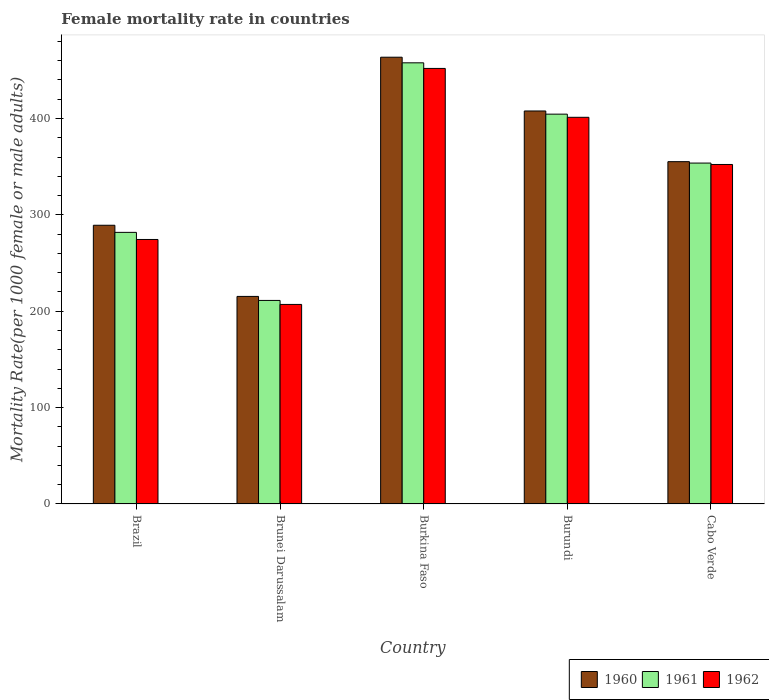How many different coloured bars are there?
Provide a short and direct response. 3. How many bars are there on the 4th tick from the right?
Ensure brevity in your answer.  3. What is the label of the 3rd group of bars from the left?
Keep it short and to the point. Burkina Faso. In how many cases, is the number of bars for a given country not equal to the number of legend labels?
Ensure brevity in your answer.  0. What is the female mortality rate in 1960 in Burundi?
Offer a terse response. 407.84. Across all countries, what is the maximum female mortality rate in 1960?
Your answer should be compact. 463.65. Across all countries, what is the minimum female mortality rate in 1960?
Your answer should be compact. 215.4. In which country was the female mortality rate in 1962 maximum?
Make the answer very short. Burkina Faso. In which country was the female mortality rate in 1962 minimum?
Your answer should be very brief. Brunei Darussalam. What is the total female mortality rate in 1961 in the graph?
Your answer should be very brief. 1709.28. What is the difference between the female mortality rate in 1961 in Burundi and that in Cabo Verde?
Provide a succinct answer. 50.78. What is the difference between the female mortality rate in 1960 in Burundi and the female mortality rate in 1961 in Brunei Darussalam?
Ensure brevity in your answer.  196.6. What is the average female mortality rate in 1962 per country?
Your answer should be compact. 337.44. What is the difference between the female mortality rate of/in 1962 and female mortality rate of/in 1961 in Brunei Darussalam?
Your response must be concise. -4.16. In how many countries, is the female mortality rate in 1961 greater than 80?
Provide a succinct answer. 5. What is the ratio of the female mortality rate in 1962 in Brazil to that in Cabo Verde?
Offer a very short reply. 0.78. Is the female mortality rate in 1961 in Brunei Darussalam less than that in Burkina Faso?
Ensure brevity in your answer.  Yes. What is the difference between the highest and the second highest female mortality rate in 1960?
Your response must be concise. 52.6. What is the difference between the highest and the lowest female mortality rate in 1960?
Your answer should be very brief. 248.25. In how many countries, is the female mortality rate in 1960 greater than the average female mortality rate in 1960 taken over all countries?
Ensure brevity in your answer.  3. What does the 2nd bar from the right in Burkina Faso represents?
Offer a terse response. 1961. How many bars are there?
Give a very brief answer. 15. Are all the bars in the graph horizontal?
Offer a terse response. No. How many countries are there in the graph?
Give a very brief answer. 5. Are the values on the major ticks of Y-axis written in scientific E-notation?
Give a very brief answer. No. Does the graph contain grids?
Your answer should be compact. No. How are the legend labels stacked?
Give a very brief answer. Horizontal. What is the title of the graph?
Your answer should be very brief. Female mortality rate in countries. Does "1991" appear as one of the legend labels in the graph?
Make the answer very short. No. What is the label or title of the X-axis?
Keep it short and to the point. Country. What is the label or title of the Y-axis?
Offer a terse response. Mortality Rate(per 1000 female or male adults). What is the Mortality Rate(per 1000 female or male adults) in 1960 in Brazil?
Your answer should be compact. 289.25. What is the Mortality Rate(per 1000 female or male adults) of 1961 in Brazil?
Provide a succinct answer. 281.87. What is the Mortality Rate(per 1000 female or male adults) in 1962 in Brazil?
Provide a succinct answer. 274.49. What is the Mortality Rate(per 1000 female or male adults) of 1960 in Brunei Darussalam?
Provide a short and direct response. 215.4. What is the Mortality Rate(per 1000 female or male adults) in 1961 in Brunei Darussalam?
Your response must be concise. 211.24. What is the Mortality Rate(per 1000 female or male adults) in 1962 in Brunei Darussalam?
Make the answer very short. 207.09. What is the Mortality Rate(per 1000 female or male adults) of 1960 in Burkina Faso?
Keep it short and to the point. 463.65. What is the Mortality Rate(per 1000 female or male adults) in 1961 in Burkina Faso?
Offer a terse response. 457.83. What is the Mortality Rate(per 1000 female or male adults) in 1962 in Burkina Faso?
Provide a short and direct response. 452. What is the Mortality Rate(per 1000 female or male adults) of 1960 in Burundi?
Make the answer very short. 407.84. What is the Mortality Rate(per 1000 female or male adults) in 1961 in Burundi?
Provide a succinct answer. 404.56. What is the Mortality Rate(per 1000 female or male adults) in 1962 in Burundi?
Give a very brief answer. 401.28. What is the Mortality Rate(per 1000 female or male adults) of 1960 in Cabo Verde?
Offer a very short reply. 355.24. What is the Mortality Rate(per 1000 female or male adults) in 1961 in Cabo Verde?
Your response must be concise. 353.78. What is the Mortality Rate(per 1000 female or male adults) in 1962 in Cabo Verde?
Offer a very short reply. 352.33. Across all countries, what is the maximum Mortality Rate(per 1000 female or male adults) of 1960?
Provide a succinct answer. 463.65. Across all countries, what is the maximum Mortality Rate(per 1000 female or male adults) of 1961?
Make the answer very short. 457.83. Across all countries, what is the maximum Mortality Rate(per 1000 female or male adults) in 1962?
Ensure brevity in your answer.  452. Across all countries, what is the minimum Mortality Rate(per 1000 female or male adults) in 1960?
Give a very brief answer. 215.4. Across all countries, what is the minimum Mortality Rate(per 1000 female or male adults) in 1961?
Keep it short and to the point. 211.24. Across all countries, what is the minimum Mortality Rate(per 1000 female or male adults) in 1962?
Offer a very short reply. 207.09. What is the total Mortality Rate(per 1000 female or male adults) of 1960 in the graph?
Give a very brief answer. 1731.39. What is the total Mortality Rate(per 1000 female or male adults) in 1961 in the graph?
Offer a terse response. 1709.29. What is the total Mortality Rate(per 1000 female or male adults) of 1962 in the graph?
Ensure brevity in your answer.  1687.18. What is the difference between the Mortality Rate(per 1000 female or male adults) in 1960 in Brazil and that in Brunei Darussalam?
Offer a very short reply. 73.86. What is the difference between the Mortality Rate(per 1000 female or male adults) of 1961 in Brazil and that in Brunei Darussalam?
Provide a short and direct response. 70.63. What is the difference between the Mortality Rate(per 1000 female or male adults) in 1962 in Brazil and that in Brunei Darussalam?
Your answer should be very brief. 67.41. What is the difference between the Mortality Rate(per 1000 female or male adults) of 1960 in Brazil and that in Burkina Faso?
Your answer should be very brief. -174.39. What is the difference between the Mortality Rate(per 1000 female or male adults) in 1961 in Brazil and that in Burkina Faso?
Offer a terse response. -175.95. What is the difference between the Mortality Rate(per 1000 female or male adults) of 1962 in Brazil and that in Burkina Faso?
Your answer should be compact. -177.51. What is the difference between the Mortality Rate(per 1000 female or male adults) in 1960 in Brazil and that in Burundi?
Offer a very short reply. -118.59. What is the difference between the Mortality Rate(per 1000 female or male adults) in 1961 in Brazil and that in Burundi?
Your response must be concise. -122.69. What is the difference between the Mortality Rate(per 1000 female or male adults) in 1962 in Brazil and that in Burundi?
Provide a succinct answer. -126.78. What is the difference between the Mortality Rate(per 1000 female or male adults) of 1960 in Brazil and that in Cabo Verde?
Your answer should be compact. -65.99. What is the difference between the Mortality Rate(per 1000 female or male adults) in 1961 in Brazil and that in Cabo Verde?
Your answer should be compact. -71.91. What is the difference between the Mortality Rate(per 1000 female or male adults) in 1962 in Brazil and that in Cabo Verde?
Your answer should be compact. -77.83. What is the difference between the Mortality Rate(per 1000 female or male adults) of 1960 in Brunei Darussalam and that in Burkina Faso?
Your response must be concise. -248.25. What is the difference between the Mortality Rate(per 1000 female or male adults) in 1961 in Brunei Darussalam and that in Burkina Faso?
Ensure brevity in your answer.  -246.58. What is the difference between the Mortality Rate(per 1000 female or male adults) in 1962 in Brunei Darussalam and that in Burkina Faso?
Provide a succinct answer. -244.92. What is the difference between the Mortality Rate(per 1000 female or male adults) of 1960 in Brunei Darussalam and that in Burundi?
Provide a succinct answer. -192.44. What is the difference between the Mortality Rate(per 1000 female or male adults) of 1961 in Brunei Darussalam and that in Burundi?
Keep it short and to the point. -193.32. What is the difference between the Mortality Rate(per 1000 female or male adults) in 1962 in Brunei Darussalam and that in Burundi?
Provide a short and direct response. -194.19. What is the difference between the Mortality Rate(per 1000 female or male adults) in 1960 in Brunei Darussalam and that in Cabo Verde?
Offer a very short reply. -139.84. What is the difference between the Mortality Rate(per 1000 female or male adults) of 1961 in Brunei Darussalam and that in Cabo Verde?
Give a very brief answer. -142.54. What is the difference between the Mortality Rate(per 1000 female or male adults) in 1962 in Brunei Darussalam and that in Cabo Verde?
Provide a succinct answer. -145.24. What is the difference between the Mortality Rate(per 1000 female or male adults) in 1960 in Burkina Faso and that in Burundi?
Offer a terse response. 55.8. What is the difference between the Mortality Rate(per 1000 female or male adults) of 1961 in Burkina Faso and that in Burundi?
Keep it short and to the point. 53.27. What is the difference between the Mortality Rate(per 1000 female or male adults) of 1962 in Burkina Faso and that in Burundi?
Offer a very short reply. 50.73. What is the difference between the Mortality Rate(per 1000 female or male adults) of 1960 in Burkina Faso and that in Cabo Verde?
Ensure brevity in your answer.  108.41. What is the difference between the Mortality Rate(per 1000 female or male adults) in 1961 in Burkina Faso and that in Cabo Verde?
Your answer should be compact. 104.04. What is the difference between the Mortality Rate(per 1000 female or male adults) in 1962 in Burkina Faso and that in Cabo Verde?
Ensure brevity in your answer.  99.68. What is the difference between the Mortality Rate(per 1000 female or male adults) of 1960 in Burundi and that in Cabo Verde?
Provide a succinct answer. 52.6. What is the difference between the Mortality Rate(per 1000 female or male adults) in 1961 in Burundi and that in Cabo Verde?
Make the answer very short. 50.78. What is the difference between the Mortality Rate(per 1000 female or male adults) in 1962 in Burundi and that in Cabo Verde?
Keep it short and to the point. 48.95. What is the difference between the Mortality Rate(per 1000 female or male adults) of 1960 in Brazil and the Mortality Rate(per 1000 female or male adults) of 1961 in Brunei Darussalam?
Provide a short and direct response. 78.01. What is the difference between the Mortality Rate(per 1000 female or male adults) in 1960 in Brazil and the Mortality Rate(per 1000 female or male adults) in 1962 in Brunei Darussalam?
Your response must be concise. 82.17. What is the difference between the Mortality Rate(per 1000 female or male adults) of 1961 in Brazil and the Mortality Rate(per 1000 female or male adults) of 1962 in Brunei Darussalam?
Provide a short and direct response. 74.79. What is the difference between the Mortality Rate(per 1000 female or male adults) of 1960 in Brazil and the Mortality Rate(per 1000 female or male adults) of 1961 in Burkina Faso?
Your answer should be very brief. -168.57. What is the difference between the Mortality Rate(per 1000 female or male adults) of 1960 in Brazil and the Mortality Rate(per 1000 female or male adults) of 1962 in Burkina Faso?
Your answer should be compact. -162.75. What is the difference between the Mortality Rate(per 1000 female or male adults) of 1961 in Brazil and the Mortality Rate(per 1000 female or male adults) of 1962 in Burkina Faso?
Offer a terse response. -170.13. What is the difference between the Mortality Rate(per 1000 female or male adults) of 1960 in Brazil and the Mortality Rate(per 1000 female or male adults) of 1961 in Burundi?
Your answer should be very brief. -115.31. What is the difference between the Mortality Rate(per 1000 female or male adults) in 1960 in Brazil and the Mortality Rate(per 1000 female or male adults) in 1962 in Burundi?
Ensure brevity in your answer.  -112.02. What is the difference between the Mortality Rate(per 1000 female or male adults) of 1961 in Brazil and the Mortality Rate(per 1000 female or male adults) of 1962 in Burundi?
Offer a very short reply. -119.4. What is the difference between the Mortality Rate(per 1000 female or male adults) in 1960 in Brazil and the Mortality Rate(per 1000 female or male adults) in 1961 in Cabo Verde?
Give a very brief answer. -64.53. What is the difference between the Mortality Rate(per 1000 female or male adults) of 1960 in Brazil and the Mortality Rate(per 1000 female or male adults) of 1962 in Cabo Verde?
Make the answer very short. -63.07. What is the difference between the Mortality Rate(per 1000 female or male adults) in 1961 in Brazil and the Mortality Rate(per 1000 female or male adults) in 1962 in Cabo Verde?
Your response must be concise. -70.45. What is the difference between the Mortality Rate(per 1000 female or male adults) of 1960 in Brunei Darussalam and the Mortality Rate(per 1000 female or male adults) of 1961 in Burkina Faso?
Ensure brevity in your answer.  -242.43. What is the difference between the Mortality Rate(per 1000 female or male adults) of 1960 in Brunei Darussalam and the Mortality Rate(per 1000 female or male adults) of 1962 in Burkina Faso?
Ensure brevity in your answer.  -236.61. What is the difference between the Mortality Rate(per 1000 female or male adults) of 1961 in Brunei Darussalam and the Mortality Rate(per 1000 female or male adults) of 1962 in Burkina Faso?
Provide a short and direct response. -240.76. What is the difference between the Mortality Rate(per 1000 female or male adults) in 1960 in Brunei Darussalam and the Mortality Rate(per 1000 female or male adults) in 1961 in Burundi?
Give a very brief answer. -189.16. What is the difference between the Mortality Rate(per 1000 female or male adults) in 1960 in Brunei Darussalam and the Mortality Rate(per 1000 female or male adults) in 1962 in Burundi?
Make the answer very short. -185.88. What is the difference between the Mortality Rate(per 1000 female or male adults) of 1961 in Brunei Darussalam and the Mortality Rate(per 1000 female or male adults) of 1962 in Burundi?
Give a very brief answer. -190.03. What is the difference between the Mortality Rate(per 1000 female or male adults) of 1960 in Brunei Darussalam and the Mortality Rate(per 1000 female or male adults) of 1961 in Cabo Verde?
Provide a short and direct response. -138.38. What is the difference between the Mortality Rate(per 1000 female or male adults) of 1960 in Brunei Darussalam and the Mortality Rate(per 1000 female or male adults) of 1962 in Cabo Verde?
Your answer should be compact. -136.93. What is the difference between the Mortality Rate(per 1000 female or male adults) in 1961 in Brunei Darussalam and the Mortality Rate(per 1000 female or male adults) in 1962 in Cabo Verde?
Provide a succinct answer. -141.08. What is the difference between the Mortality Rate(per 1000 female or male adults) of 1960 in Burkina Faso and the Mortality Rate(per 1000 female or male adults) of 1961 in Burundi?
Your answer should be very brief. 59.09. What is the difference between the Mortality Rate(per 1000 female or male adults) of 1960 in Burkina Faso and the Mortality Rate(per 1000 female or male adults) of 1962 in Burundi?
Keep it short and to the point. 62.37. What is the difference between the Mortality Rate(per 1000 female or male adults) of 1961 in Burkina Faso and the Mortality Rate(per 1000 female or male adults) of 1962 in Burundi?
Provide a short and direct response. 56.55. What is the difference between the Mortality Rate(per 1000 female or male adults) of 1960 in Burkina Faso and the Mortality Rate(per 1000 female or male adults) of 1961 in Cabo Verde?
Offer a terse response. 109.86. What is the difference between the Mortality Rate(per 1000 female or male adults) in 1960 in Burkina Faso and the Mortality Rate(per 1000 female or male adults) in 1962 in Cabo Verde?
Give a very brief answer. 111.32. What is the difference between the Mortality Rate(per 1000 female or male adults) of 1961 in Burkina Faso and the Mortality Rate(per 1000 female or male adults) of 1962 in Cabo Verde?
Make the answer very short. 105.5. What is the difference between the Mortality Rate(per 1000 female or male adults) in 1960 in Burundi and the Mortality Rate(per 1000 female or male adults) in 1961 in Cabo Verde?
Offer a terse response. 54.06. What is the difference between the Mortality Rate(per 1000 female or male adults) of 1960 in Burundi and the Mortality Rate(per 1000 female or male adults) of 1962 in Cabo Verde?
Provide a succinct answer. 55.52. What is the difference between the Mortality Rate(per 1000 female or male adults) in 1961 in Burundi and the Mortality Rate(per 1000 female or male adults) in 1962 in Cabo Verde?
Your response must be concise. 52.23. What is the average Mortality Rate(per 1000 female or male adults) in 1960 per country?
Ensure brevity in your answer.  346.28. What is the average Mortality Rate(per 1000 female or male adults) in 1961 per country?
Your response must be concise. 341.86. What is the average Mortality Rate(per 1000 female or male adults) in 1962 per country?
Ensure brevity in your answer.  337.44. What is the difference between the Mortality Rate(per 1000 female or male adults) in 1960 and Mortality Rate(per 1000 female or male adults) in 1961 in Brazil?
Your response must be concise. 7.38. What is the difference between the Mortality Rate(per 1000 female or male adults) in 1960 and Mortality Rate(per 1000 female or male adults) in 1962 in Brazil?
Ensure brevity in your answer.  14.76. What is the difference between the Mortality Rate(per 1000 female or male adults) in 1961 and Mortality Rate(per 1000 female or male adults) in 1962 in Brazil?
Ensure brevity in your answer.  7.38. What is the difference between the Mortality Rate(per 1000 female or male adults) in 1960 and Mortality Rate(per 1000 female or male adults) in 1961 in Brunei Darussalam?
Your answer should be very brief. 4.16. What is the difference between the Mortality Rate(per 1000 female or male adults) of 1960 and Mortality Rate(per 1000 female or male adults) of 1962 in Brunei Darussalam?
Provide a succinct answer. 8.31. What is the difference between the Mortality Rate(per 1000 female or male adults) of 1961 and Mortality Rate(per 1000 female or male adults) of 1962 in Brunei Darussalam?
Give a very brief answer. 4.16. What is the difference between the Mortality Rate(per 1000 female or male adults) in 1960 and Mortality Rate(per 1000 female or male adults) in 1961 in Burkina Faso?
Provide a short and direct response. 5.82. What is the difference between the Mortality Rate(per 1000 female or male adults) in 1960 and Mortality Rate(per 1000 female or male adults) in 1962 in Burkina Faso?
Provide a succinct answer. 11.64. What is the difference between the Mortality Rate(per 1000 female or male adults) of 1961 and Mortality Rate(per 1000 female or male adults) of 1962 in Burkina Faso?
Ensure brevity in your answer.  5.82. What is the difference between the Mortality Rate(per 1000 female or male adults) in 1960 and Mortality Rate(per 1000 female or male adults) in 1961 in Burundi?
Offer a very short reply. 3.28. What is the difference between the Mortality Rate(per 1000 female or male adults) of 1960 and Mortality Rate(per 1000 female or male adults) of 1962 in Burundi?
Your response must be concise. 6.57. What is the difference between the Mortality Rate(per 1000 female or male adults) of 1961 and Mortality Rate(per 1000 female or male adults) of 1962 in Burundi?
Your response must be concise. 3.28. What is the difference between the Mortality Rate(per 1000 female or male adults) of 1960 and Mortality Rate(per 1000 female or male adults) of 1961 in Cabo Verde?
Your answer should be very brief. 1.46. What is the difference between the Mortality Rate(per 1000 female or male adults) of 1960 and Mortality Rate(per 1000 female or male adults) of 1962 in Cabo Verde?
Provide a succinct answer. 2.92. What is the difference between the Mortality Rate(per 1000 female or male adults) of 1961 and Mortality Rate(per 1000 female or male adults) of 1962 in Cabo Verde?
Provide a short and direct response. 1.46. What is the ratio of the Mortality Rate(per 1000 female or male adults) in 1960 in Brazil to that in Brunei Darussalam?
Your answer should be very brief. 1.34. What is the ratio of the Mortality Rate(per 1000 female or male adults) in 1961 in Brazil to that in Brunei Darussalam?
Offer a terse response. 1.33. What is the ratio of the Mortality Rate(per 1000 female or male adults) in 1962 in Brazil to that in Brunei Darussalam?
Your answer should be compact. 1.33. What is the ratio of the Mortality Rate(per 1000 female or male adults) in 1960 in Brazil to that in Burkina Faso?
Provide a succinct answer. 0.62. What is the ratio of the Mortality Rate(per 1000 female or male adults) in 1961 in Brazil to that in Burkina Faso?
Offer a very short reply. 0.62. What is the ratio of the Mortality Rate(per 1000 female or male adults) in 1962 in Brazil to that in Burkina Faso?
Keep it short and to the point. 0.61. What is the ratio of the Mortality Rate(per 1000 female or male adults) of 1960 in Brazil to that in Burundi?
Your answer should be compact. 0.71. What is the ratio of the Mortality Rate(per 1000 female or male adults) in 1961 in Brazil to that in Burundi?
Keep it short and to the point. 0.7. What is the ratio of the Mortality Rate(per 1000 female or male adults) of 1962 in Brazil to that in Burundi?
Ensure brevity in your answer.  0.68. What is the ratio of the Mortality Rate(per 1000 female or male adults) in 1960 in Brazil to that in Cabo Verde?
Give a very brief answer. 0.81. What is the ratio of the Mortality Rate(per 1000 female or male adults) in 1961 in Brazil to that in Cabo Verde?
Make the answer very short. 0.8. What is the ratio of the Mortality Rate(per 1000 female or male adults) of 1962 in Brazil to that in Cabo Verde?
Your response must be concise. 0.78. What is the ratio of the Mortality Rate(per 1000 female or male adults) of 1960 in Brunei Darussalam to that in Burkina Faso?
Keep it short and to the point. 0.46. What is the ratio of the Mortality Rate(per 1000 female or male adults) in 1961 in Brunei Darussalam to that in Burkina Faso?
Offer a terse response. 0.46. What is the ratio of the Mortality Rate(per 1000 female or male adults) of 1962 in Brunei Darussalam to that in Burkina Faso?
Provide a succinct answer. 0.46. What is the ratio of the Mortality Rate(per 1000 female or male adults) in 1960 in Brunei Darussalam to that in Burundi?
Offer a terse response. 0.53. What is the ratio of the Mortality Rate(per 1000 female or male adults) in 1961 in Brunei Darussalam to that in Burundi?
Keep it short and to the point. 0.52. What is the ratio of the Mortality Rate(per 1000 female or male adults) of 1962 in Brunei Darussalam to that in Burundi?
Provide a succinct answer. 0.52. What is the ratio of the Mortality Rate(per 1000 female or male adults) of 1960 in Brunei Darussalam to that in Cabo Verde?
Your response must be concise. 0.61. What is the ratio of the Mortality Rate(per 1000 female or male adults) in 1961 in Brunei Darussalam to that in Cabo Verde?
Your response must be concise. 0.6. What is the ratio of the Mortality Rate(per 1000 female or male adults) of 1962 in Brunei Darussalam to that in Cabo Verde?
Your answer should be compact. 0.59. What is the ratio of the Mortality Rate(per 1000 female or male adults) in 1960 in Burkina Faso to that in Burundi?
Offer a terse response. 1.14. What is the ratio of the Mortality Rate(per 1000 female or male adults) of 1961 in Burkina Faso to that in Burundi?
Offer a very short reply. 1.13. What is the ratio of the Mortality Rate(per 1000 female or male adults) of 1962 in Burkina Faso to that in Burundi?
Your answer should be very brief. 1.13. What is the ratio of the Mortality Rate(per 1000 female or male adults) in 1960 in Burkina Faso to that in Cabo Verde?
Provide a succinct answer. 1.31. What is the ratio of the Mortality Rate(per 1000 female or male adults) of 1961 in Burkina Faso to that in Cabo Verde?
Provide a succinct answer. 1.29. What is the ratio of the Mortality Rate(per 1000 female or male adults) in 1962 in Burkina Faso to that in Cabo Verde?
Provide a short and direct response. 1.28. What is the ratio of the Mortality Rate(per 1000 female or male adults) of 1960 in Burundi to that in Cabo Verde?
Give a very brief answer. 1.15. What is the ratio of the Mortality Rate(per 1000 female or male adults) in 1961 in Burundi to that in Cabo Verde?
Keep it short and to the point. 1.14. What is the ratio of the Mortality Rate(per 1000 female or male adults) of 1962 in Burundi to that in Cabo Verde?
Provide a succinct answer. 1.14. What is the difference between the highest and the second highest Mortality Rate(per 1000 female or male adults) in 1960?
Make the answer very short. 55.8. What is the difference between the highest and the second highest Mortality Rate(per 1000 female or male adults) in 1961?
Make the answer very short. 53.27. What is the difference between the highest and the second highest Mortality Rate(per 1000 female or male adults) in 1962?
Keep it short and to the point. 50.73. What is the difference between the highest and the lowest Mortality Rate(per 1000 female or male adults) in 1960?
Your answer should be compact. 248.25. What is the difference between the highest and the lowest Mortality Rate(per 1000 female or male adults) of 1961?
Keep it short and to the point. 246.58. What is the difference between the highest and the lowest Mortality Rate(per 1000 female or male adults) of 1962?
Offer a terse response. 244.92. 